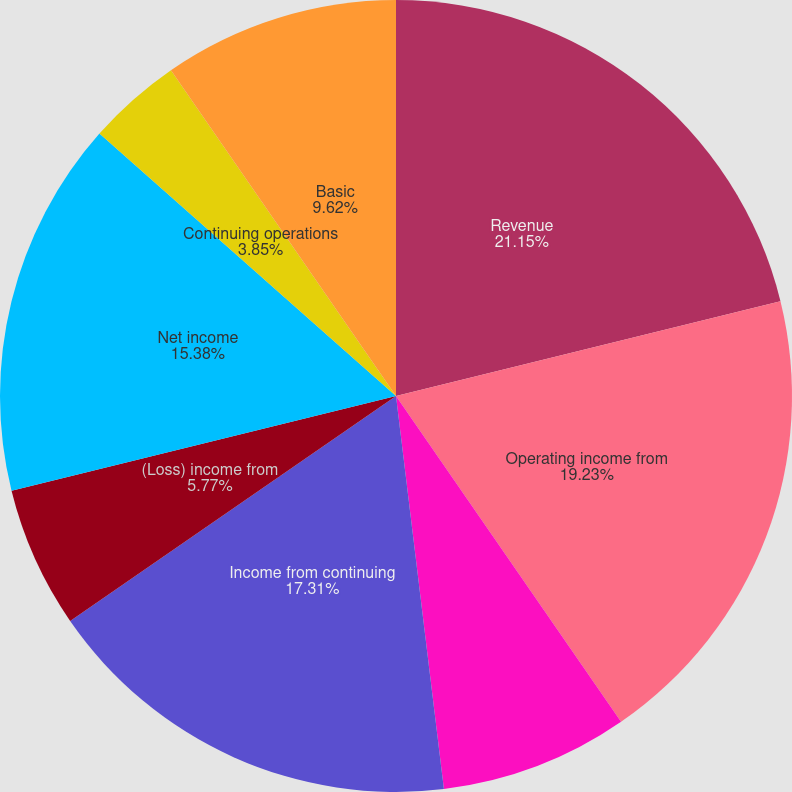<chart> <loc_0><loc_0><loc_500><loc_500><pie_chart><fcel>Revenue<fcel>Operating income from<fcel>Interest and other expense<fcel>Income from continuing<fcel>(Loss) income from<fcel>Net income<fcel>Continuing operations<fcel>Discontinued operations<fcel>Basic<nl><fcel>21.15%<fcel>19.23%<fcel>7.69%<fcel>17.31%<fcel>5.77%<fcel>15.38%<fcel>3.85%<fcel>0.0%<fcel>9.62%<nl></chart> 